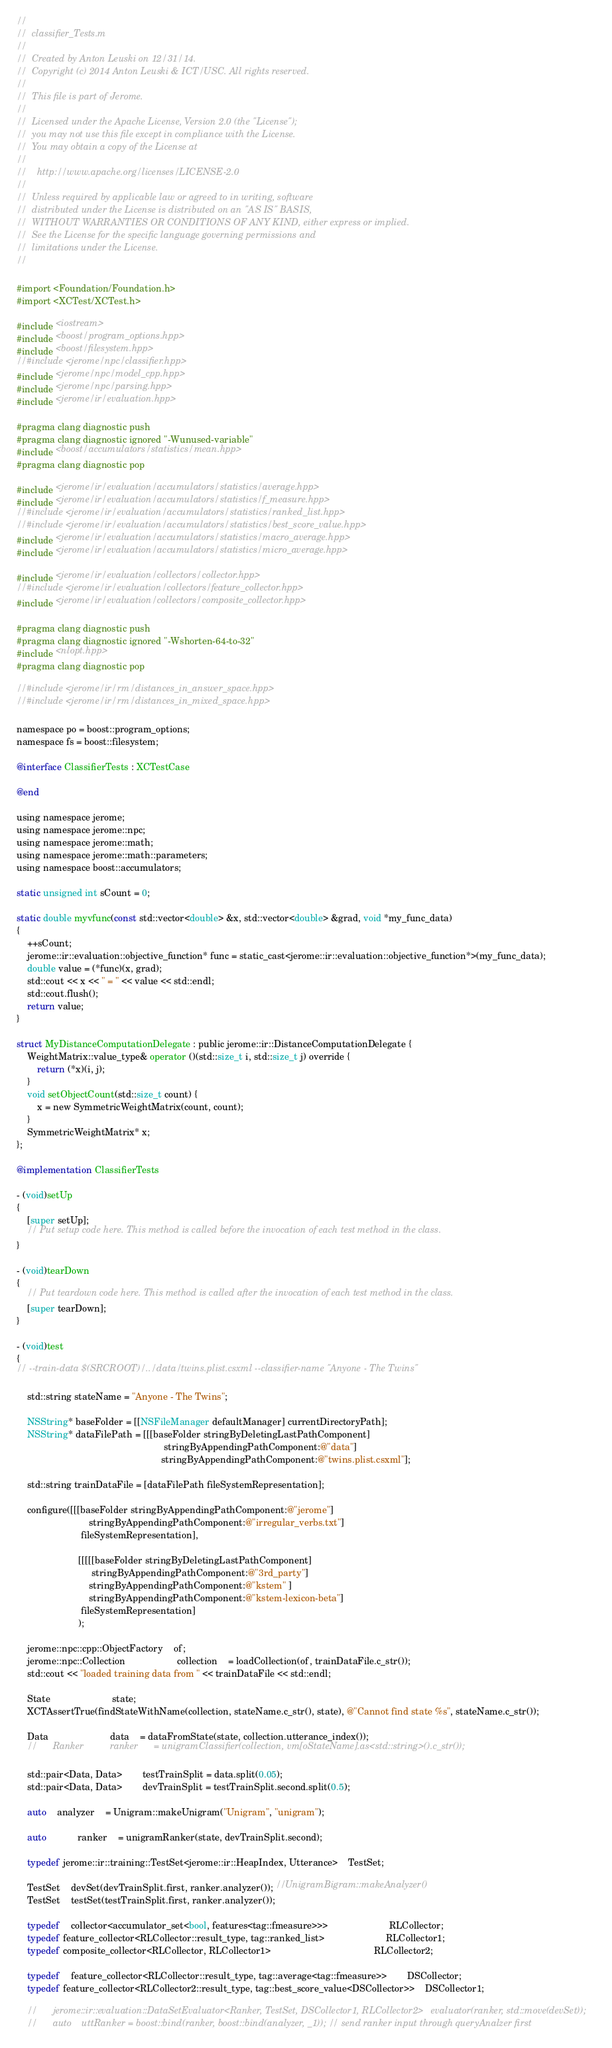Convert code to text. <code><loc_0><loc_0><loc_500><loc_500><_ObjectiveC_>//
//  classifier_Tests.m
//
//  Created by Anton Leuski on 12/31/14.
//  Copyright (c) 2014 Anton Leuski & ICT/USC. All rights reserved.
//
//  This file is part of Jerome.
//
//  Licensed under the Apache License, Version 2.0 (the "License");
//  you may not use this file except in compliance with the License.
//  You may obtain a copy of the License at
//
//    http://www.apache.org/licenses/LICENSE-2.0
//
//  Unless required by applicable law or agreed to in writing, software
//  distributed under the License is distributed on an "AS IS" BASIS,
//  WITHOUT WARRANTIES OR CONDITIONS OF ANY KIND, either express or implied.
//  See the License for the specific language governing permissions and
//  limitations under the License.
//

#import <Foundation/Foundation.h>
#import <XCTest/XCTest.h>

#include <iostream>
#include <boost/program_options.hpp>
#include <boost/filesystem.hpp>
//#include <jerome/npc/classifier.hpp>
#include <jerome/npc/model_cpp.hpp>
#include <jerome/npc/parsing.hpp>
#include <jerome/ir/evaluation.hpp>

#pragma clang diagnostic push
#pragma clang diagnostic ignored "-Wunused-variable"
#include <boost/accumulators/statistics/mean.hpp>
#pragma clang diagnostic pop

#include <jerome/ir/evaluation/accumulators/statistics/average.hpp>
#include <jerome/ir/evaluation/accumulators/statistics/f_measure.hpp>
//#include <jerome/ir/evaluation/accumulators/statistics/ranked_list.hpp>
//#include <jerome/ir/evaluation/accumulators/statistics/best_score_value.hpp>
#include <jerome/ir/evaluation/accumulators/statistics/macro_average.hpp>
#include <jerome/ir/evaluation/accumulators/statistics/micro_average.hpp>

#include <jerome/ir/evaluation/collectors/collector.hpp>
//#include <jerome/ir/evaluation/collectors/feature_collector.hpp>
#include <jerome/ir/evaluation/collectors/composite_collector.hpp>

#pragma clang diagnostic push
#pragma clang diagnostic ignored "-Wshorten-64-to-32"
#include <nlopt.hpp>
#pragma clang diagnostic pop

//#include <jerome/ir/rm/distances_in_answer_space.hpp>
//#include <jerome/ir/rm/distances_in_mixed_space.hpp>

namespace po = boost::program_options;
namespace fs = boost::filesystem;

@interface ClassifierTests : XCTestCase

@end

using namespace jerome;
using namespace jerome::npc;
using namespace jerome::math;
using namespace jerome::math::parameters;
using namespace boost::accumulators;

static unsigned int sCount = 0;

static double myvfunc(const std::vector<double> &x, std::vector<double> &grad, void *my_func_data)
{
	++sCount;
	jerome::ir::evaluation::objective_function* func = static_cast<jerome::ir::evaluation::objective_function*>(my_func_data);
	double value = (*func)(x, grad);
	std::cout << x << " = " << value << std::endl;
	std::cout.flush();
	return value;
}

struct MyDistanceComputationDelegate : public jerome::ir::DistanceComputationDelegate {
	WeightMatrix::value_type& operator ()(std::size_t i, std::size_t j) override {
		return (*x)(i, j);
	}
	void setObjectCount(std::size_t count) {
		x = new SymmetricWeightMatrix(count, count);
	}
	SymmetricWeightMatrix* x;
};

@implementation ClassifierTests

- (void)setUp
{
	[super setUp];
	// Put setup code here. This method is called before the invocation of each test method in the class.
}

- (void)tearDown
{
	// Put teardown code here. This method is called after the invocation of each test method in the class.
	[super tearDown];
}

- (void)test
{
// --train-data $(SRCROOT)/../data/twins.plist.csxml --classifier-name "Anyone - The Twins"
	
	std::string stateName = "Anyone - The Twins";
	
	NSString* baseFolder = [[NSFileManager defaultManager] currentDirectoryPath];
	NSString* dataFilePath = [[[baseFolder stringByDeletingLastPathComponent]
														 stringByAppendingPathComponent:@"data"]
														stringByAppendingPathComponent:@"twins.plist.csxml"];
	
	std::string trainDataFile = [dataFilePath fileSystemRepresentation];
	
	configure([[[baseFolder stringByAppendingPathComponent:@"jerome"]
							stringByAppendingPathComponent:@"irregular_verbs.txt"]
						 fileSystemRepresentation],
						
						[[[[[baseFolder stringByDeletingLastPathComponent]
							 stringByAppendingPathComponent:@"3rd_party"]
							stringByAppendingPathComponent:@"kstem" ]
							stringByAppendingPathComponent:@"kstem-lexicon-beta"]
						 fileSystemRepresentation]
						);
	
	jerome::npc::cpp::ObjectFactory	of;
	jerome::npc::Collection					collection 	= loadCollection(of, trainDataFile.c_str());
	std::cout << "loaded training data from " << trainDataFile << std::endl;
	
	State						state;
	XCTAssertTrue(findStateWithName(collection, stateName.c_str(), state), @"Cannot find state %s", stateName.c_str());
	
	Data						data	= dataFromState(state, collection.utterance_index());
	//		Ranker			ranker		= unigramClassifier(collection, vm[oStateName].as<std::string>().c_str());
	
	std::pair<Data, Data>		testTrainSplit = data.split(0.05);
	std::pair<Data, Data>		devTrainSplit = testTrainSplit.second.split(0.5);
	
	auto	analyzer	= Unigram::makeUnigram("Unigram", "unigram");
	
	auto			ranker	= unigramRanker(state, devTrainSplit.second);
	
	typedef jerome::ir::training::TestSet<jerome::ir::HeapIndex, Utterance>	TestSet;
	
	TestSet	devSet(devTrainSplit.first, ranker.analyzer()); //UnigramBigram::makeAnalyzer()
	TestSet	testSet(testTrainSplit.first, ranker.analyzer());
	
	typedef	collector<accumulator_set<bool, features<tag::fmeasure>>>						RLCollector;
	typedef feature_collector<RLCollector::result_type, tag::ranked_list>						RLCollector1;
	typedef composite_collector<RLCollector, RLCollector1>										RLCollector2;
	
	typedef	feature_collector<RLCollector::result_type, tag::average<tag::fmeasure>>		DSCollector;
	typedef feature_collector<RLCollector2::result_type, tag::best_score_value<DSCollector>>	DSCollector1;
	
	//		jerome::ir::evaluation::DataSetEvaluator<Ranker, TestSet, DSCollector1, RLCollector2>	evaluator(ranker, std::move(devSet));
	//		auto	uttRanker = boost::bind(ranker, boost::bind(analyzer, _1)); // send ranker input through queryAnalzer first</code> 